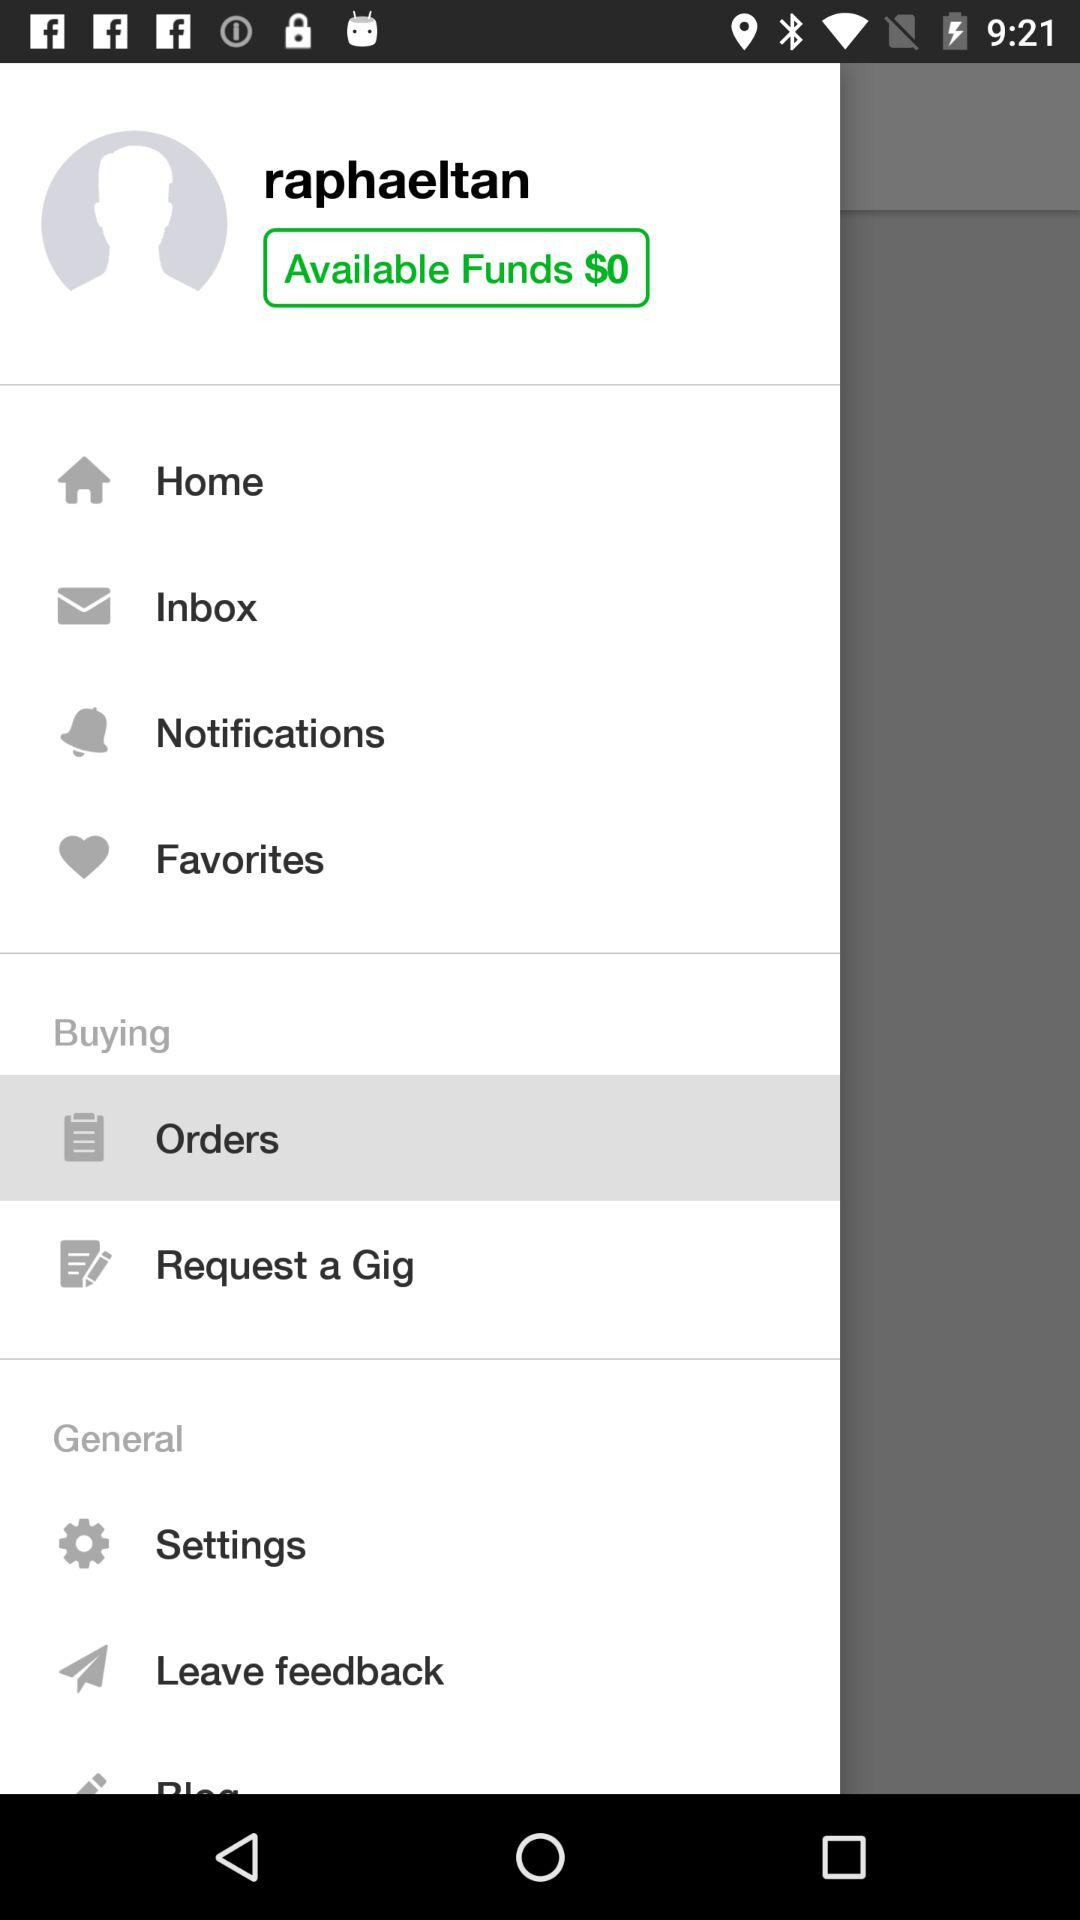What are the available funds? The available funds are $0. 